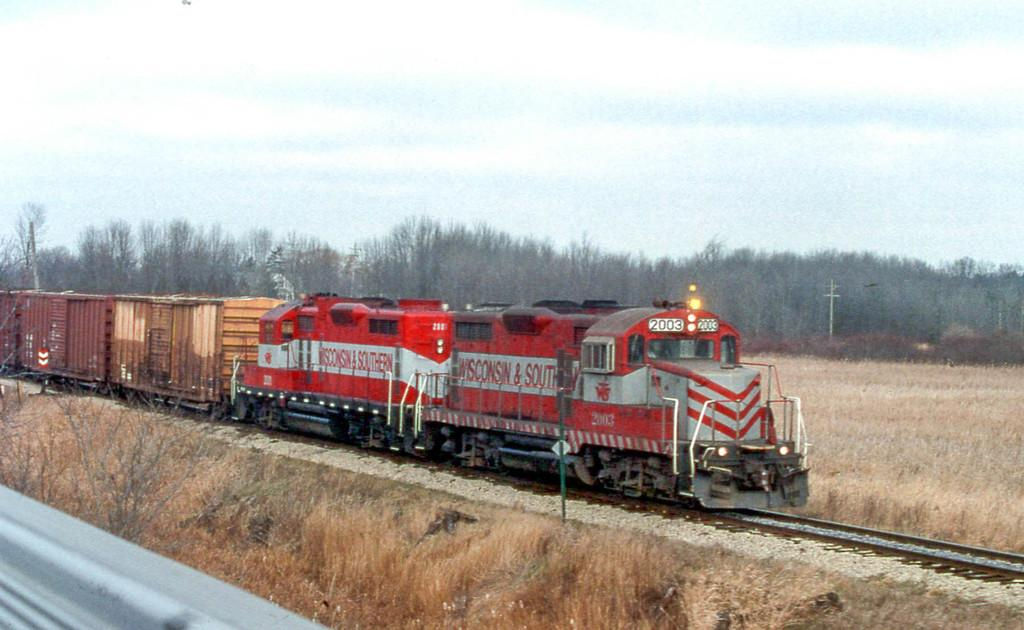What is the main subject in the foreground of the image? There is a train in the foreground of the image. What is the train doing in the image? The train is moving on a track. What type of vegetation is present on either side of the track? Grass is present on either side of the track. What can be seen in the background of the image? There are trees, poles, and the sky visible in the background of the image. What is the condition of the sky in the image? The sky is visible in the background of the image, and there are clouds present. What type of shoes can be seen hanging from the trees in the image? There are no shoes present in the image, and therefore none can be seen hanging from the trees. 